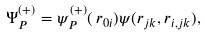<formula> <loc_0><loc_0><loc_500><loc_500>\Psi _ { P } ^ { ( + ) } = \psi _ { P } ^ { ( + ) } ( \, { r } _ { 0 i } ) \psi ( { r } _ { j k } , { r } _ { i , j k } ) ,</formula> 